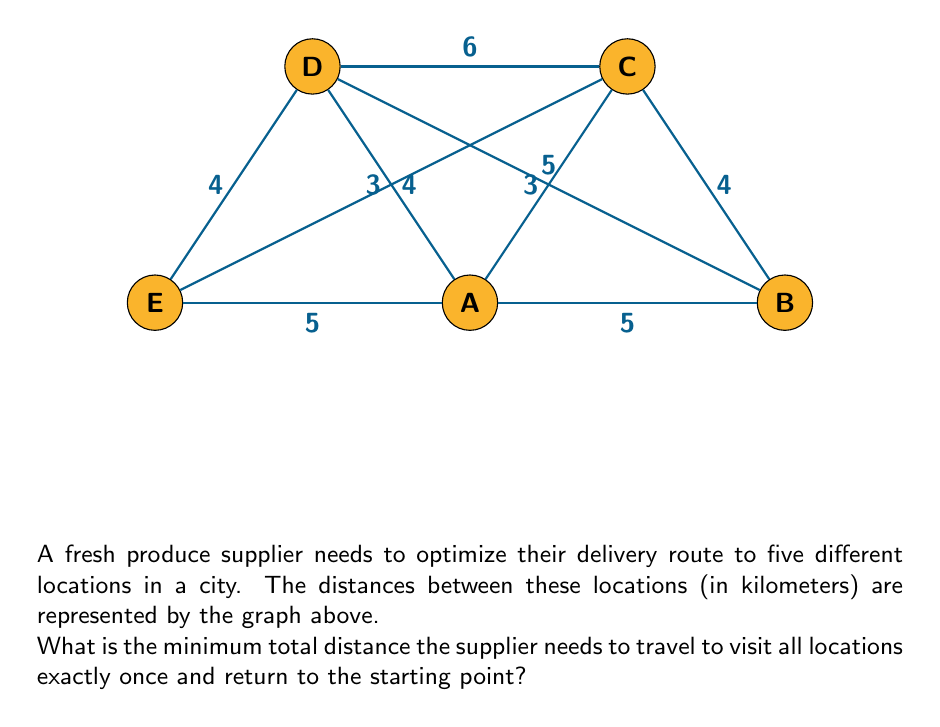Can you solve this math problem? To solve this problem, we need to find the Hamiltonian cycle with the minimum total weight in the given graph. This is known as the Traveling Salesman Problem (TSP).

For a small graph like this, we can use the brute force method to find the optimal solution:

1) List all possible Hamiltonian cycles:
   ABCDEA, ABCEDA, ABDCEA, ABDECA, ABEDCA, ABECDA
   (and their reverses, which have the same total distance)

2) Calculate the total distance for each cycle:
   ABCDEA: 5 + 4 + 6 + 4 + 5 = 24
   ABCEDA: 5 + 4 + 4 + 4 + 5 = 22
   ABDCEA: 5 + 5 + 6 + 4 + 5 = 25
   ABDECA: 5 + 5 + 4 + 4 + 5 = 23
   ABEDCA: 5 + 5 + 4 + 6 + 3 = 23
   ABECDA: 5 + 4 + 4 + 6 + 3 = 22

3) The minimum total distance is 22 km, which can be achieved by two routes: ABCEDA or ABECDA.

Therefore, the supplier needs to travel a minimum of 22 km to visit all locations once and return to the starting point.
Answer: 22 km 